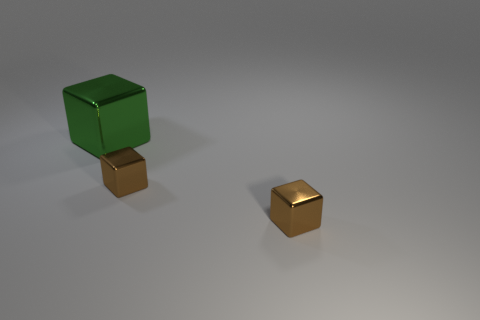Subtract all brown blocks. How many blocks are left? 1 Subtract 3 blocks. How many blocks are left? 0 Add 1 green things. How many objects exist? 4 Subtract all brown cubes. How many cubes are left? 1 Subtract all brown cubes. Subtract all brown spheres. How many cubes are left? 1 Subtract all cyan cylinders. How many green cubes are left? 1 Subtract all small red rubber things. Subtract all brown blocks. How many objects are left? 1 Add 3 tiny brown blocks. How many tiny brown blocks are left? 5 Add 1 tiny gray rubber cubes. How many tiny gray rubber cubes exist? 1 Subtract 0 brown spheres. How many objects are left? 3 